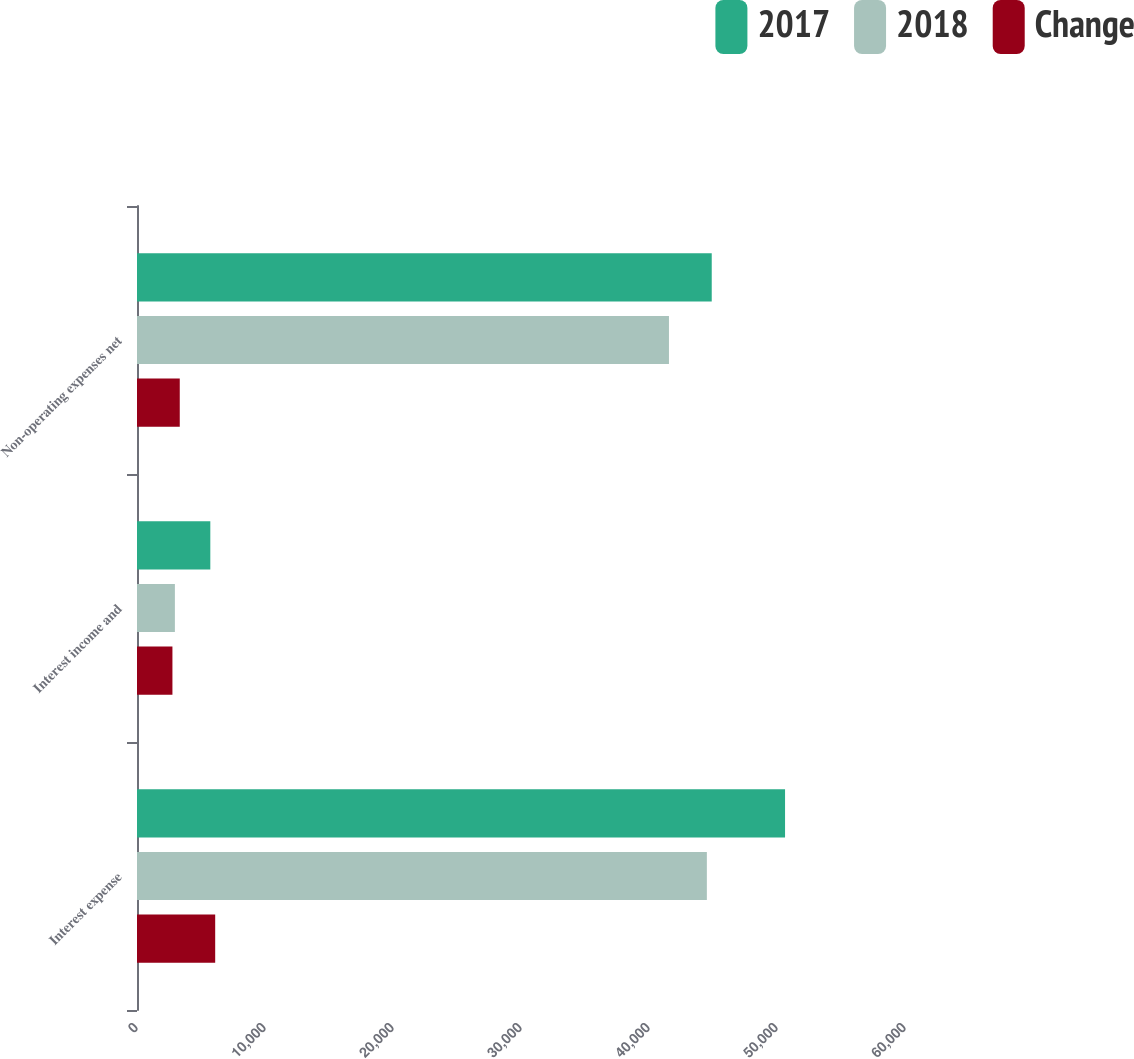Convert chart. <chart><loc_0><loc_0><loc_500><loc_500><stacked_bar_chart><ecel><fcel>Interest expense<fcel>Interest income and<fcel>Non-operating expenses net<nl><fcel>2017<fcel>50629<fcel>5728<fcel>44901<nl><fcel>2018<fcel>44520<fcel>2960<fcel>41560<nl><fcel>Change<fcel>6109<fcel>2768<fcel>3341<nl></chart> 